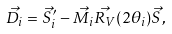<formula> <loc_0><loc_0><loc_500><loc_500>\vec { D _ { i } } = \vec { S } ^ { \prime } _ { i } - \vec { M _ { i } } \vec { R _ { V } } ( 2 \theta _ { i } ) \vec { S } ,</formula> 